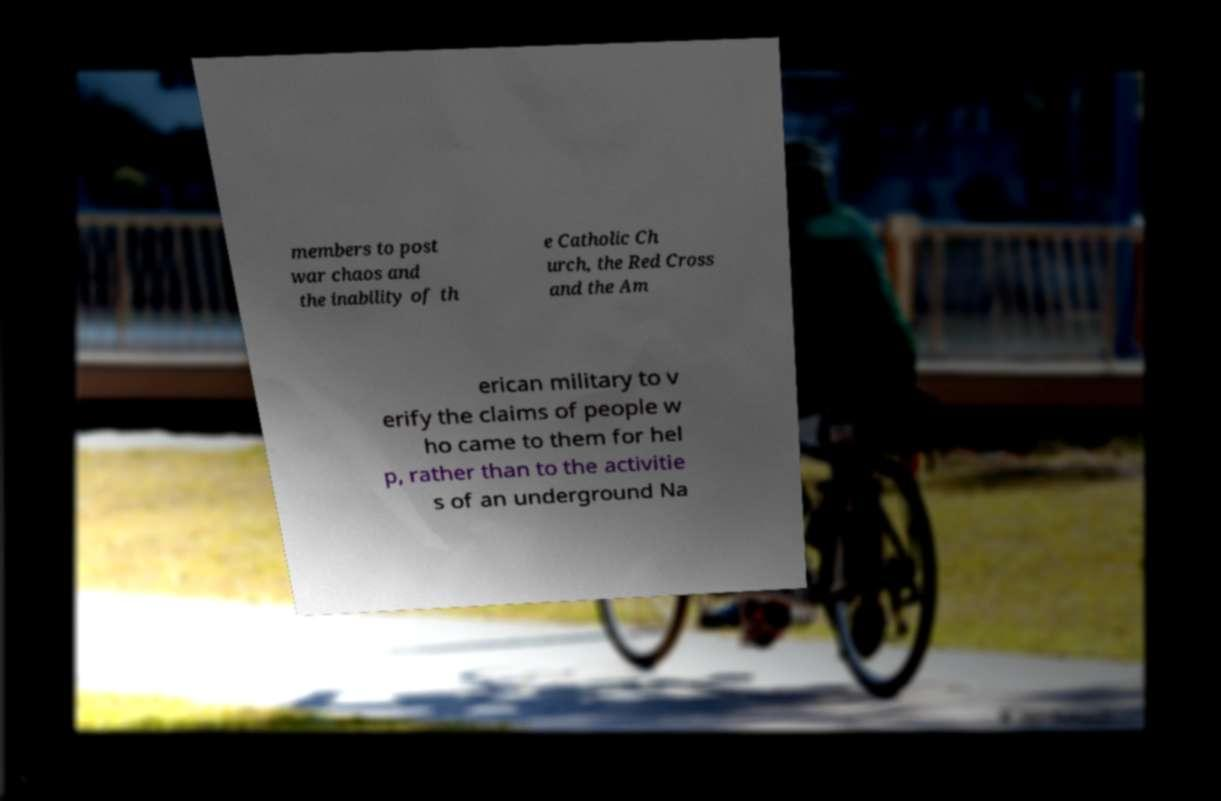Can you accurately transcribe the text from the provided image for me? members to post war chaos and the inability of th e Catholic Ch urch, the Red Cross and the Am erican military to v erify the claims of people w ho came to them for hel p, rather than to the activitie s of an underground Na 